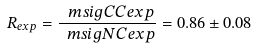Convert formula to latex. <formula><loc_0><loc_0><loc_500><loc_500>R _ { e x p } = \frac { \ m s i g { C C } { e x p } } { \ m s i g { N C } { e x p } } = 0 . 8 6 \pm 0 . 0 8</formula> 